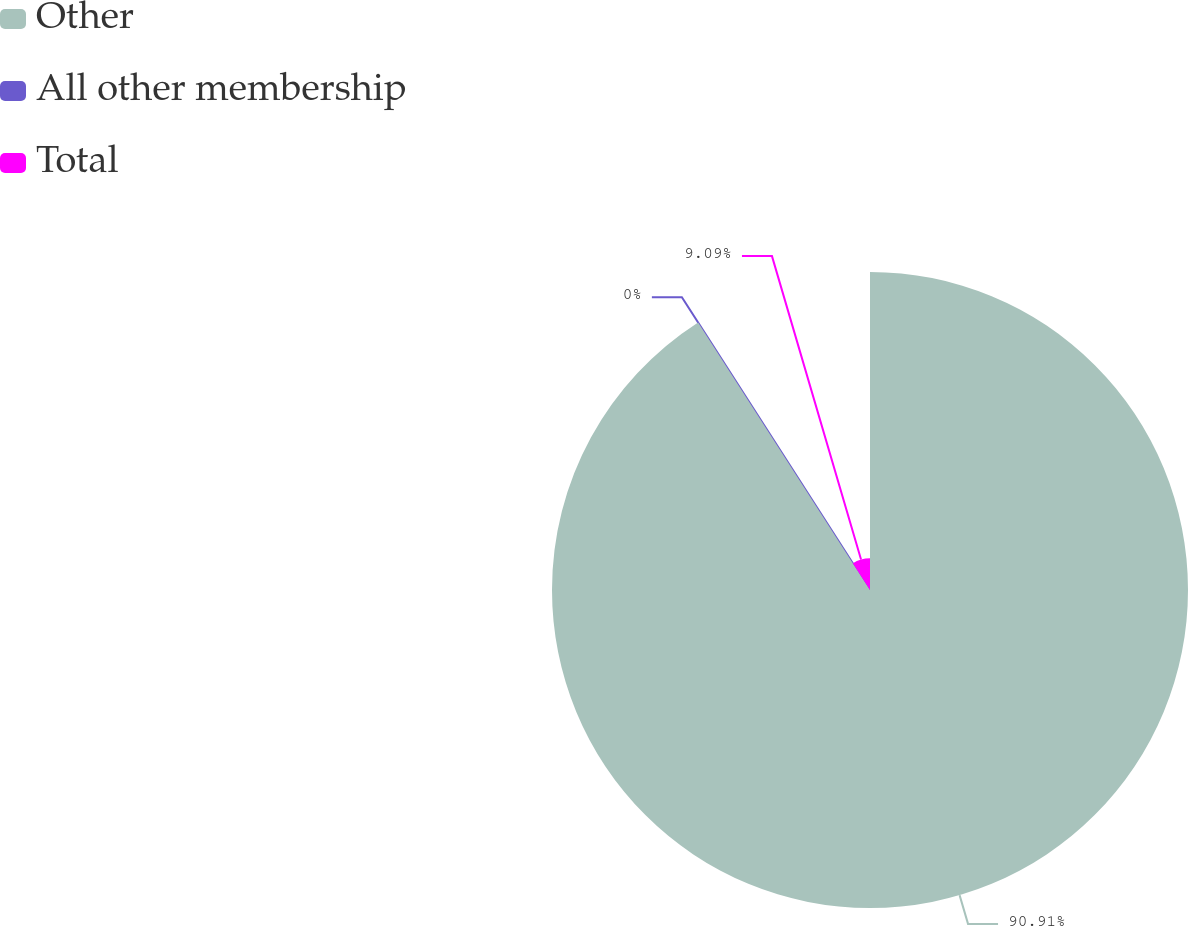<chart> <loc_0><loc_0><loc_500><loc_500><pie_chart><fcel>Other<fcel>All other membership<fcel>Total<nl><fcel>90.91%<fcel>0.0%<fcel>9.09%<nl></chart> 